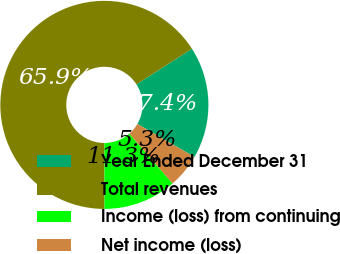Convert chart. <chart><loc_0><loc_0><loc_500><loc_500><pie_chart><fcel>Year Ended December 31<fcel>Total revenues<fcel>Income (loss) from continuing<fcel>Net income (loss)<nl><fcel>17.42%<fcel>65.95%<fcel>11.35%<fcel>5.29%<nl></chart> 